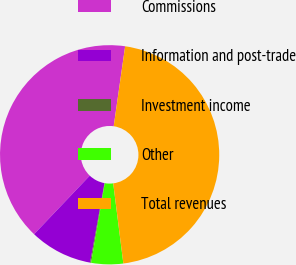Convert chart to OTSL. <chart><loc_0><loc_0><loc_500><loc_500><pie_chart><fcel>Commissions<fcel>Information and post-trade<fcel>Investment income<fcel>Other<fcel>Total revenues<nl><fcel>40.16%<fcel>9.26%<fcel>0.14%<fcel>4.7%<fcel>45.74%<nl></chart> 